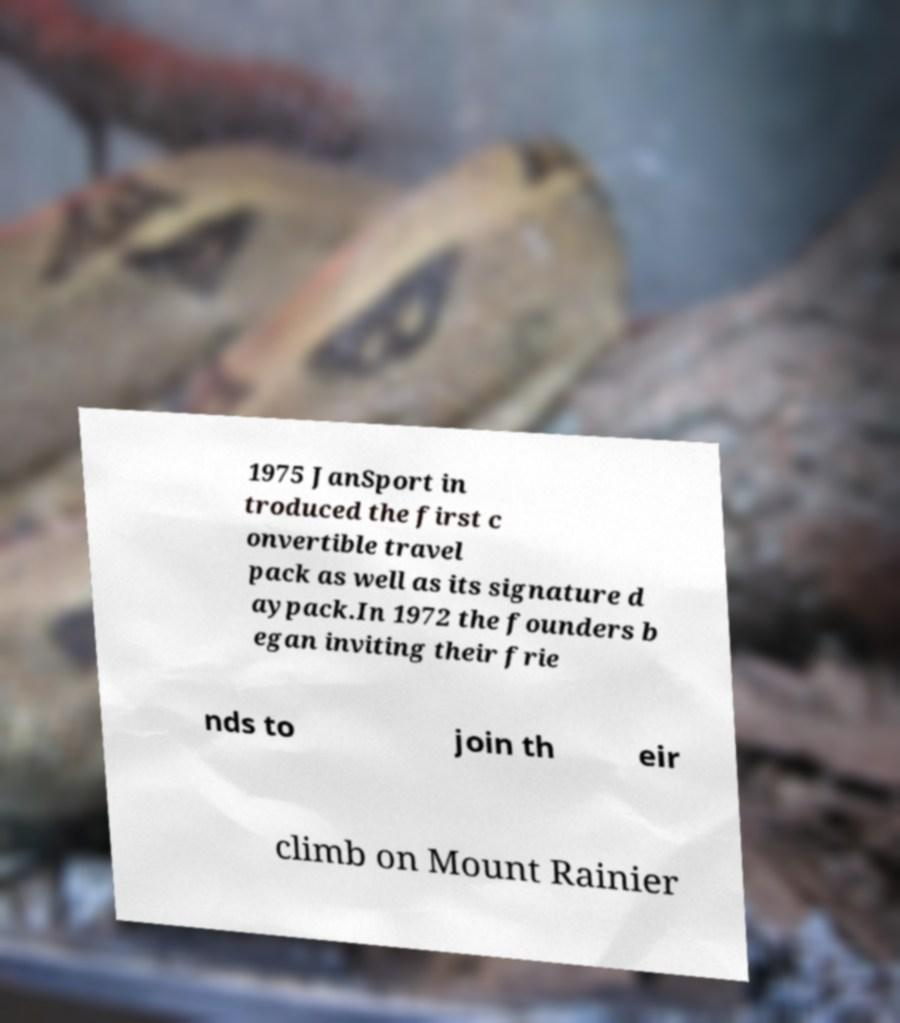Please identify and transcribe the text found in this image. 1975 JanSport in troduced the first c onvertible travel pack as well as its signature d aypack.In 1972 the founders b egan inviting their frie nds to join th eir climb on Mount Rainier 